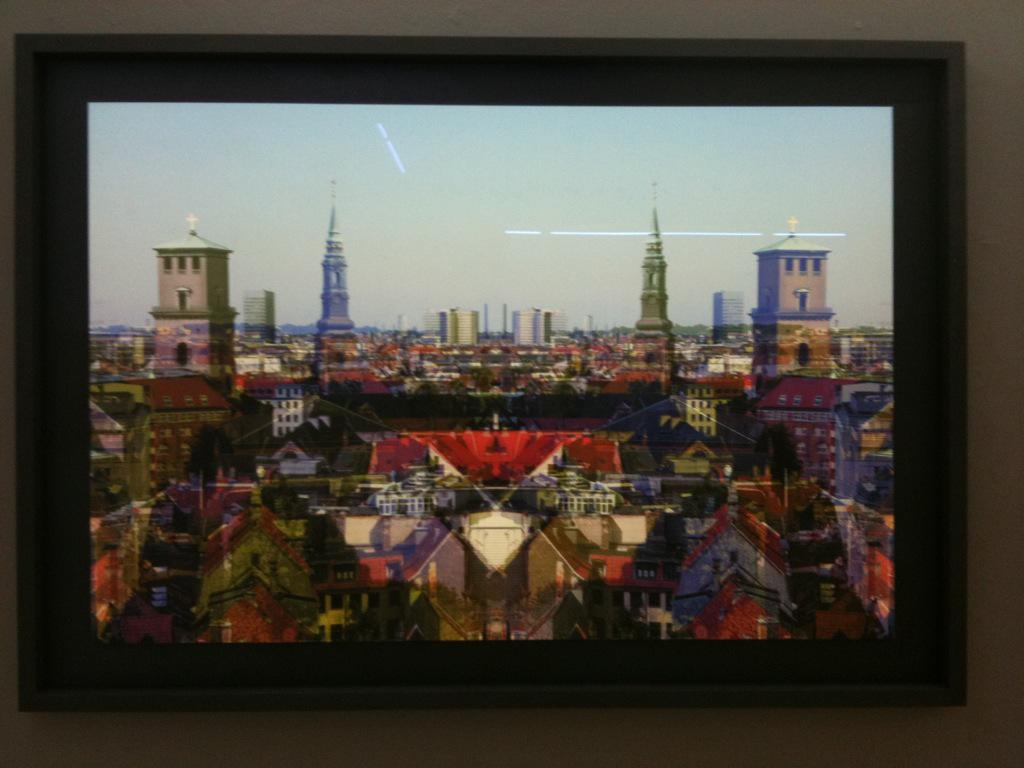What object is present in the image that typically holds a picture? There is a photo frame in the image. What is depicted in the photo frame? The photo frame contains a picture of buildings. What part of the natural environment can be seen in the photo frame? The sky is visible in the photo frame. How many children are playing with a cracker in the image? There are no children or crackers present in the image. What is the value of the cent in the image? There is no cent or any currency depicted in the image. 